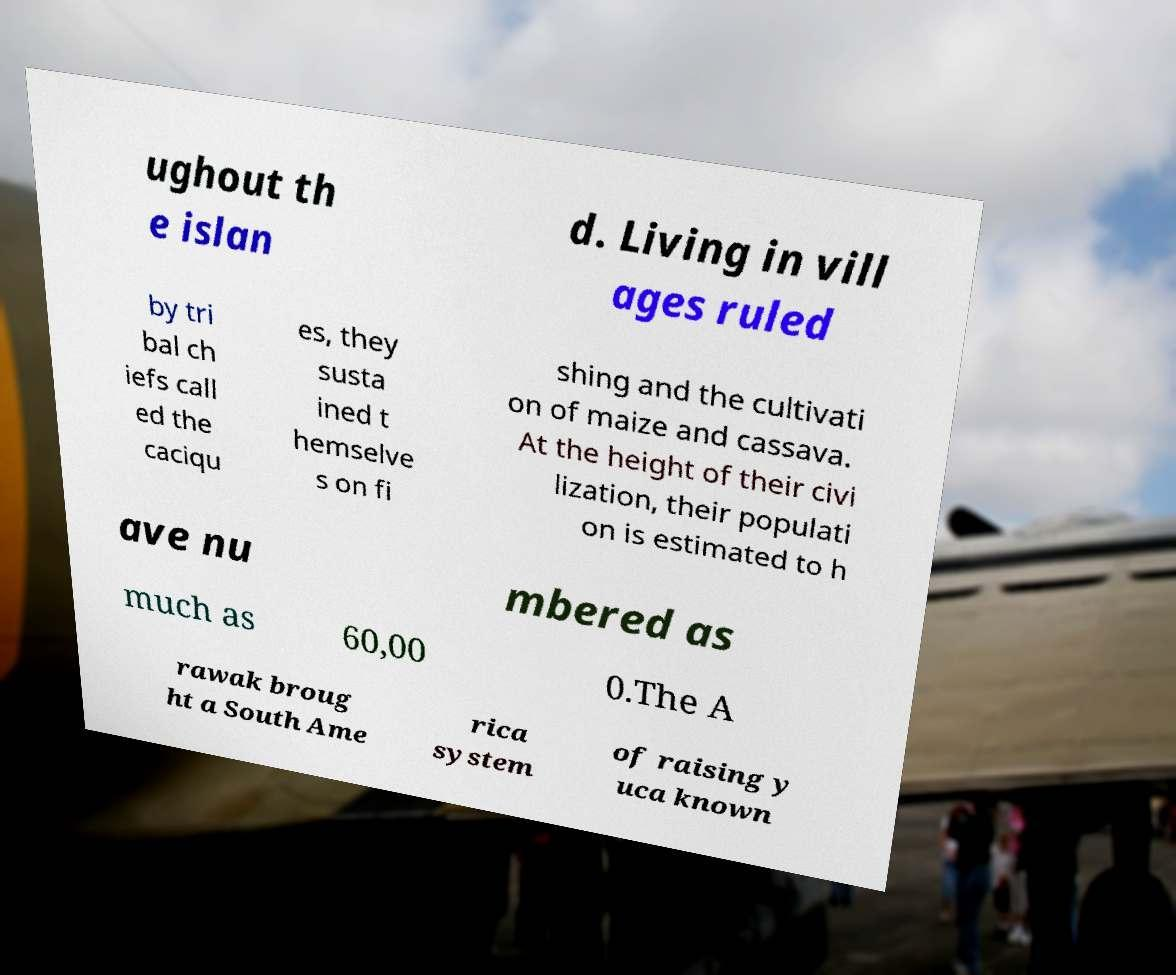For documentation purposes, I need the text within this image transcribed. Could you provide that? ughout th e islan d. Living in vill ages ruled by tri bal ch iefs call ed the caciqu es, they susta ined t hemselve s on fi shing and the cultivati on of maize and cassava. At the height of their civi lization, their populati on is estimated to h ave nu mbered as much as 60,00 0.The A rawak broug ht a South Ame rica system of raising y uca known 